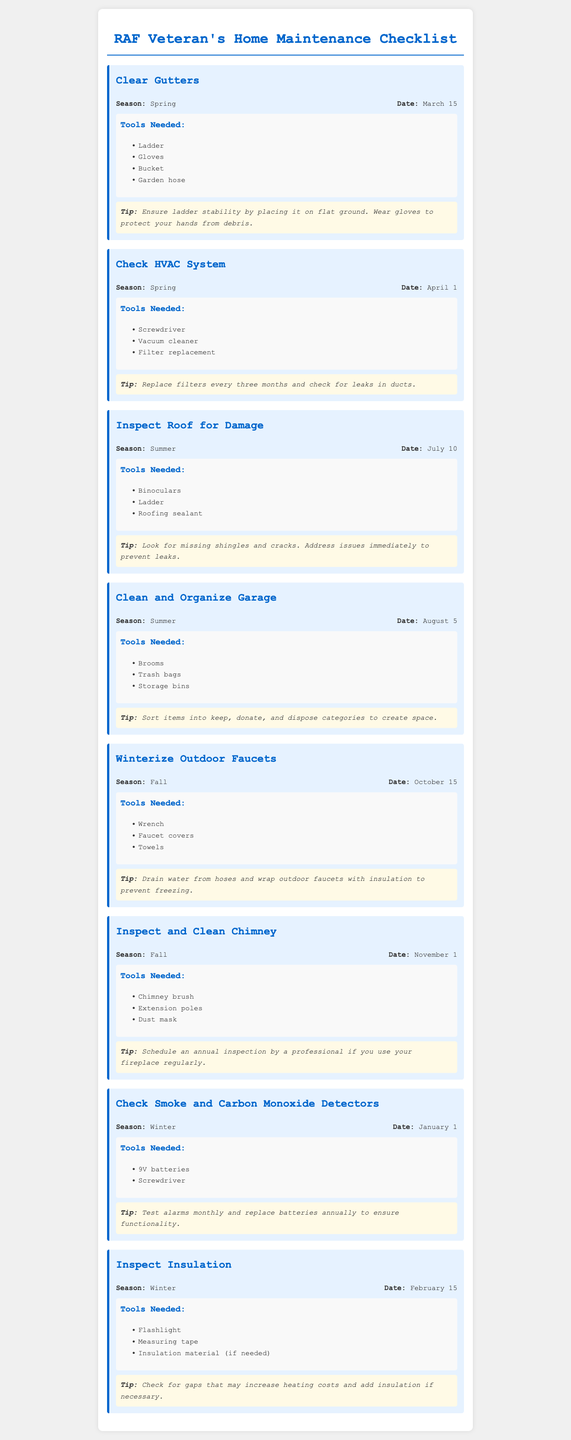What is the date to check smoke and carbon monoxide detectors? The document lists January 1 as the date for this task.
Answer: January 1 What tools are needed to winterize outdoor faucets? The task section specifies a wrench, faucet covers, and towels as the required tools.
Answer: Wrench, faucet covers, towels Which task is scheduled for July? The document mentions inspecting the roof for damage as the task for July 10.
Answer: Inspect Roof for Damage How often should HVAC filters be replaced? The advice in the document states that filters should be replaced every three months.
Answer: Every three months What season is best for cleaning and organizing the garage? According to the document, the garage should be cleaned and organized in the summer.
Answer: Summer What is the tip for clearing gutters? The document advises ensuring ladder stability by placing it on flat ground and wearing gloves.
Answer: Ensure ladder stability and wear gloves How many seasonal tasks are listed in the document? The document outlines a total of eight distinct seasonal maintenance tasks.
Answer: Eight What is the date for inspecting insulation? The task for inspecting insulation is set for February 15.
Answer: February 15 Which tasks occur in the fall season? The document lists winterizing outdoor faucets and inspecting and cleaning the chimney as fall tasks.
Answer: Winterize Outdoor Faucets, Inspect and Clean Chimney 